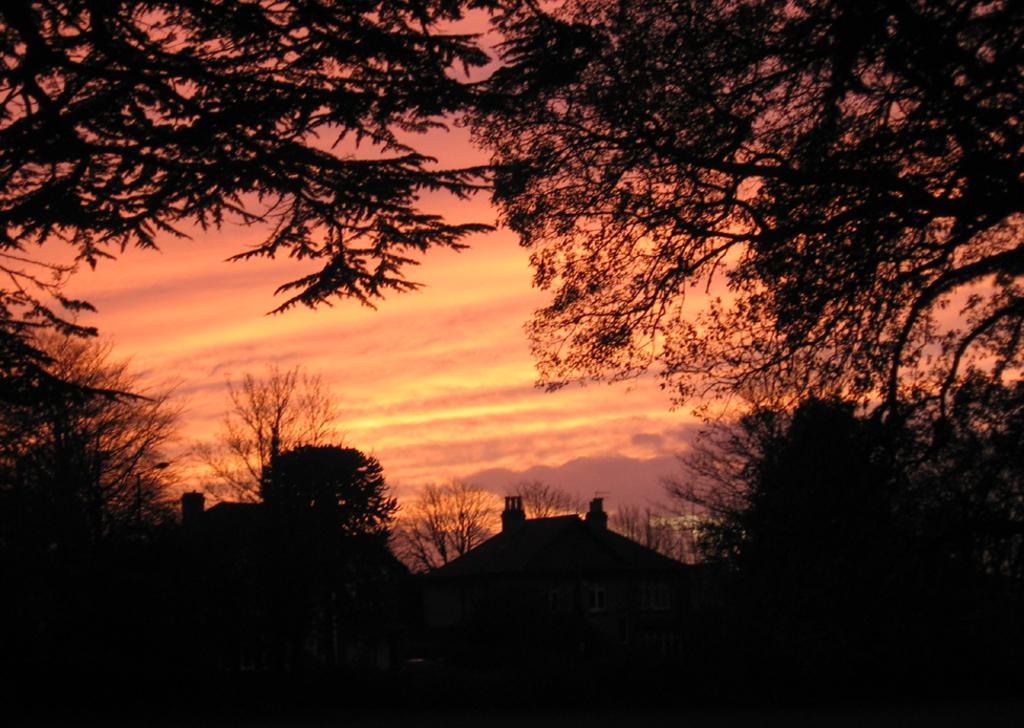Describe this image in one or two sentences. This image is looking dark. In this image there are trees, buildings and sky. 